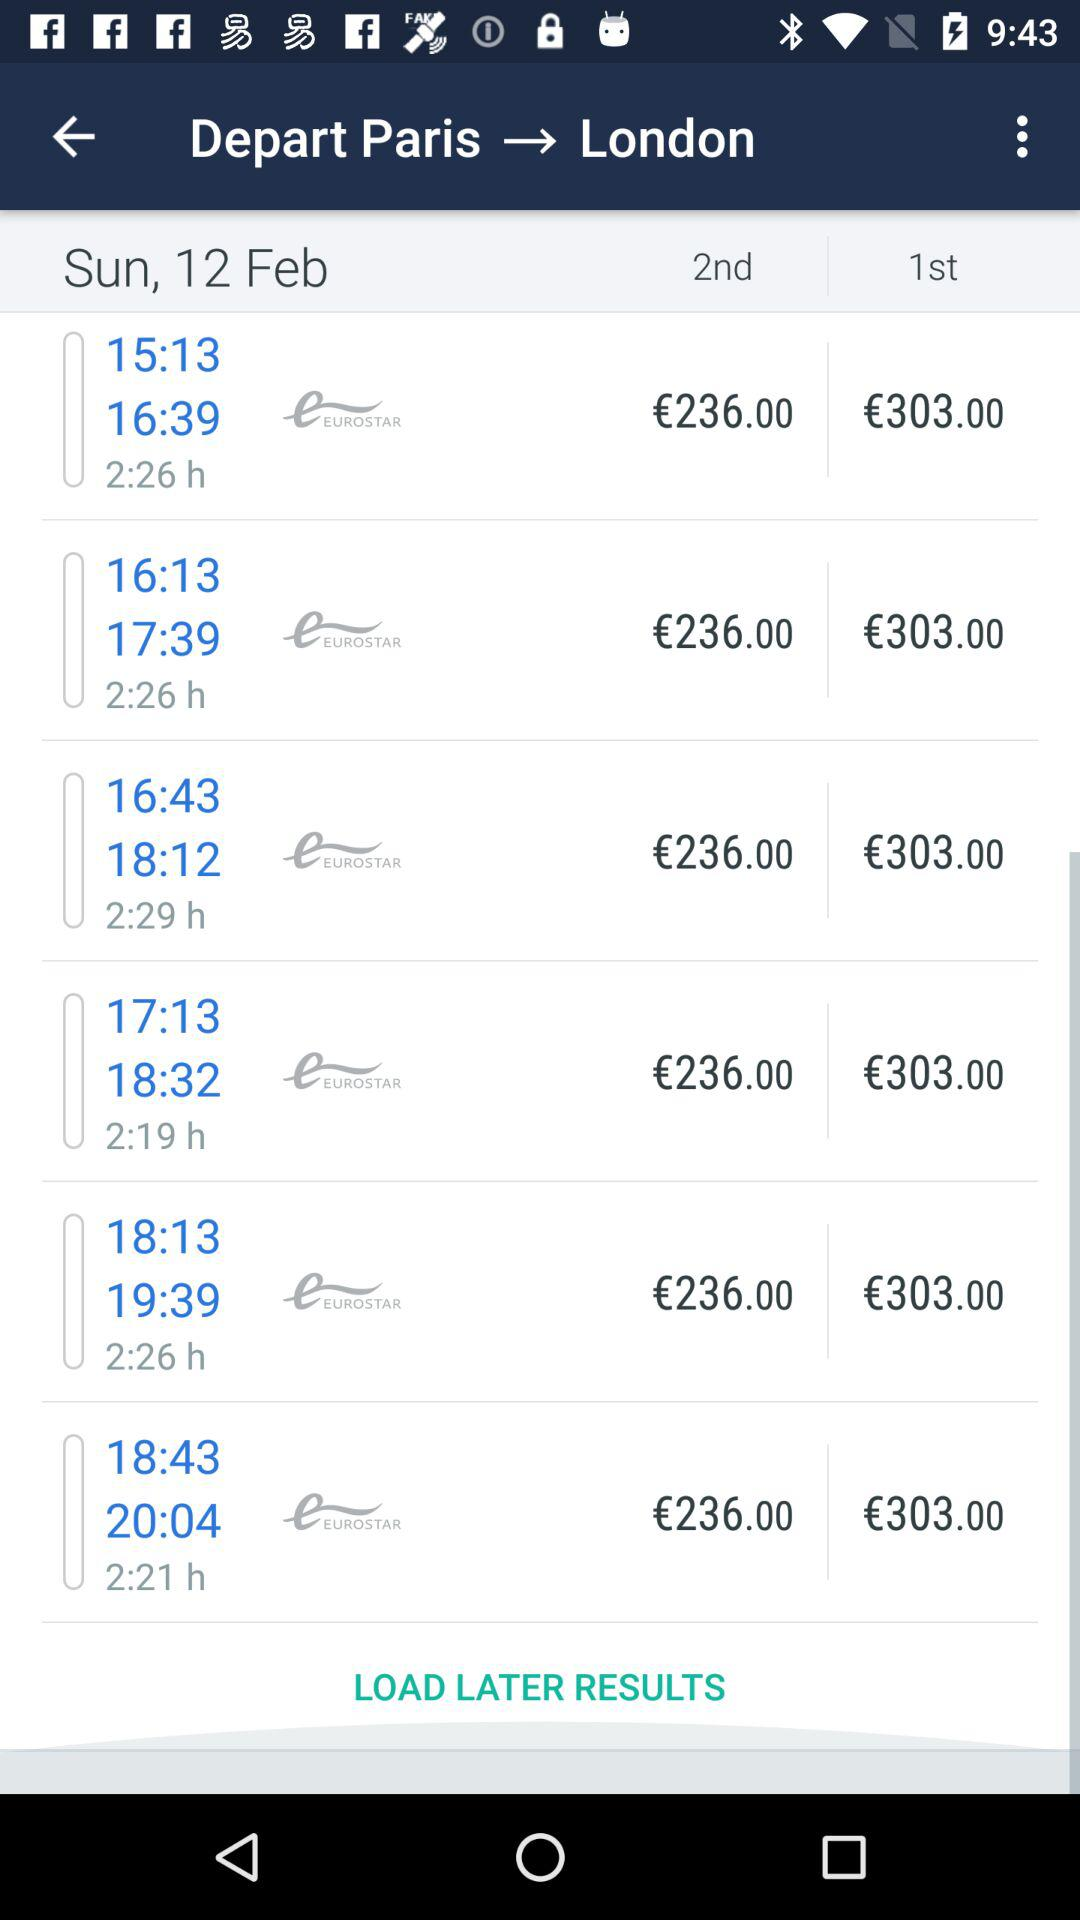How much more expensive is the 1st class ticket than the 2nd class ticket?
Answer the question using a single word or phrase. €67.00 